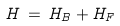Convert formula to latex. <formula><loc_0><loc_0><loc_500><loc_500>H \, = \, H _ { B } + H _ { F }</formula> 